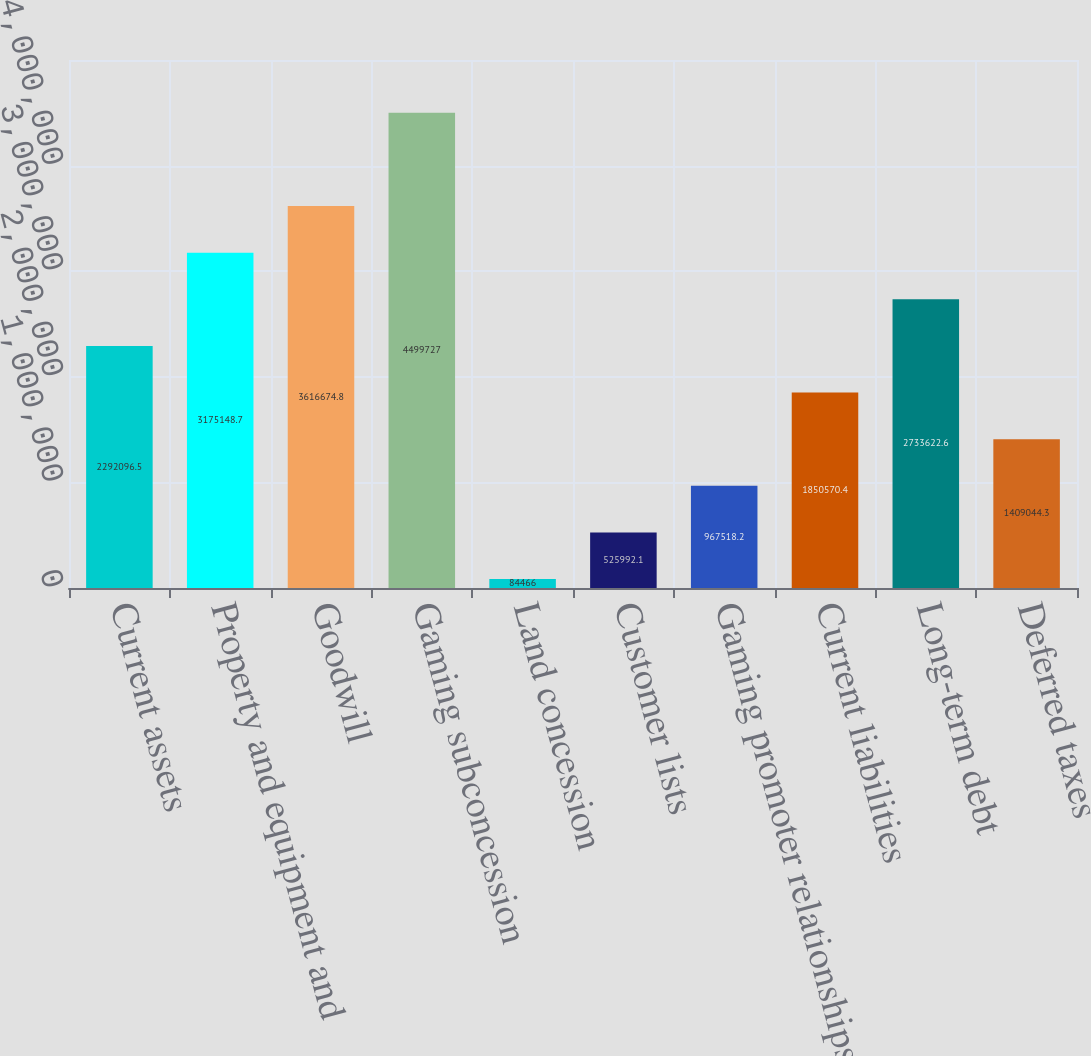<chart> <loc_0><loc_0><loc_500><loc_500><bar_chart><fcel>Current assets<fcel>Property and equipment and<fcel>Goodwill<fcel>Gaming subconcession<fcel>Land concession<fcel>Customer lists<fcel>Gaming promoter relationships<fcel>Current liabilities<fcel>Long-term debt<fcel>Deferred taxes<nl><fcel>2.2921e+06<fcel>3.17515e+06<fcel>3.61667e+06<fcel>4.49973e+06<fcel>84466<fcel>525992<fcel>967518<fcel>1.85057e+06<fcel>2.73362e+06<fcel>1.40904e+06<nl></chart> 